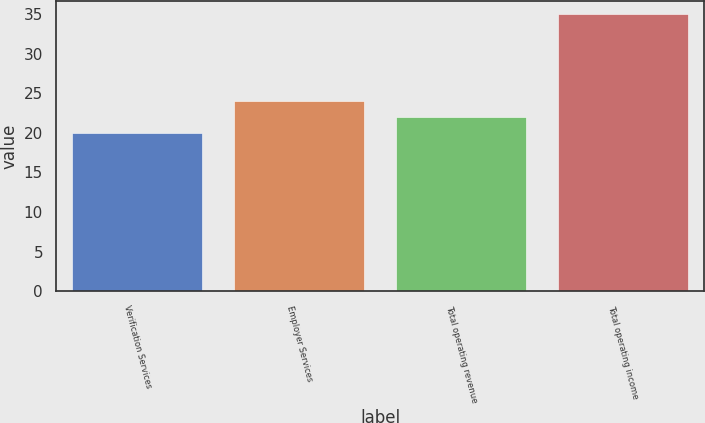Convert chart to OTSL. <chart><loc_0><loc_0><loc_500><loc_500><bar_chart><fcel>Verification Services<fcel>Employer Services<fcel>Total operating revenue<fcel>Total operating income<nl><fcel>20<fcel>24<fcel>22<fcel>35<nl></chart> 